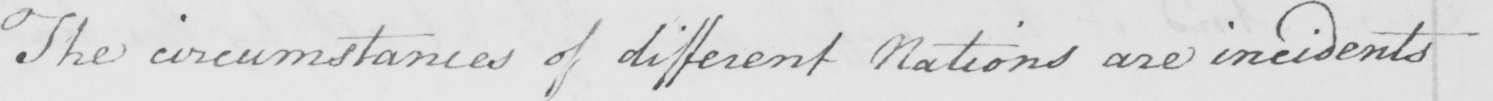Please transcribe the handwritten text in this image. The circumstances of different Nations are incidents 